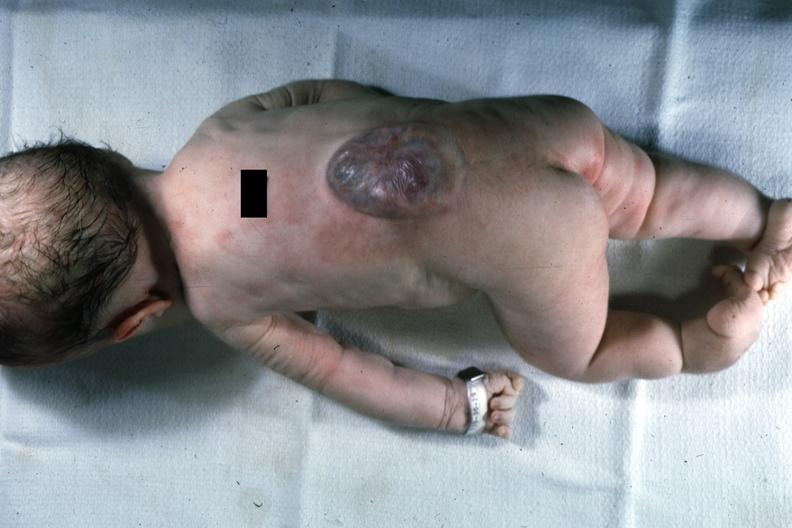does this photo of infant from head to toe show typical lesion?
Answer the question using a single word or phrase. Yes 